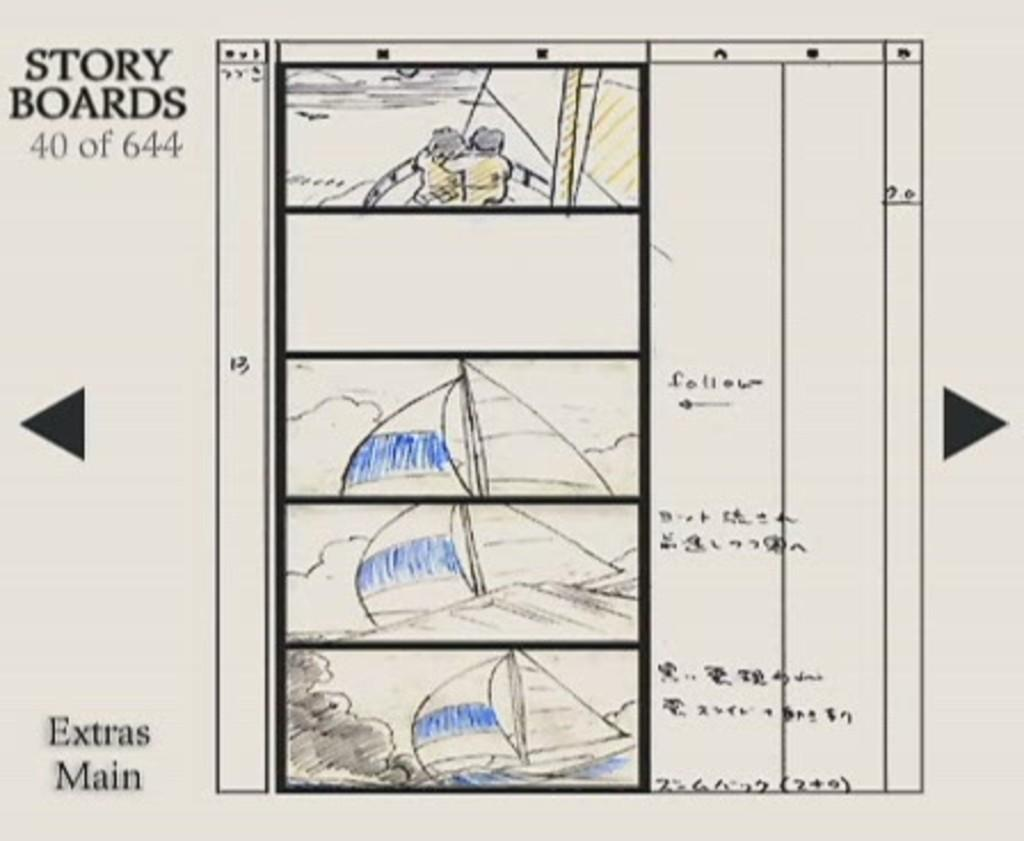What is the main subject of the image? The main subject of the image is a picture. Where is the text located in the image? There is text written in the left top corner and the left bottom corner of the image. How does the process of digestion affect the plants in the garden depicted in the image? There is no garden or mention of digestion in the image; it only contains a picture and text in the corners. 